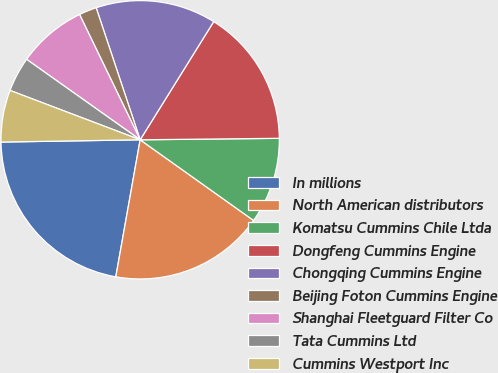Convert chart to OTSL. <chart><loc_0><loc_0><loc_500><loc_500><pie_chart><fcel>In millions<fcel>North American distributors<fcel>Komatsu Cummins Chile Ltda<fcel>Dongfeng Cummins Engine<fcel>Chongqing Cummins Engine<fcel>Beijing Foton Cummins Engine<fcel>Shanghai Fleetguard Filter Co<fcel>Tata Cummins Ltd<fcel>Cummins Westport Inc<nl><fcel>21.94%<fcel>17.96%<fcel>10.01%<fcel>15.97%<fcel>13.98%<fcel>2.05%<fcel>8.02%<fcel>4.04%<fcel>6.03%<nl></chart> 